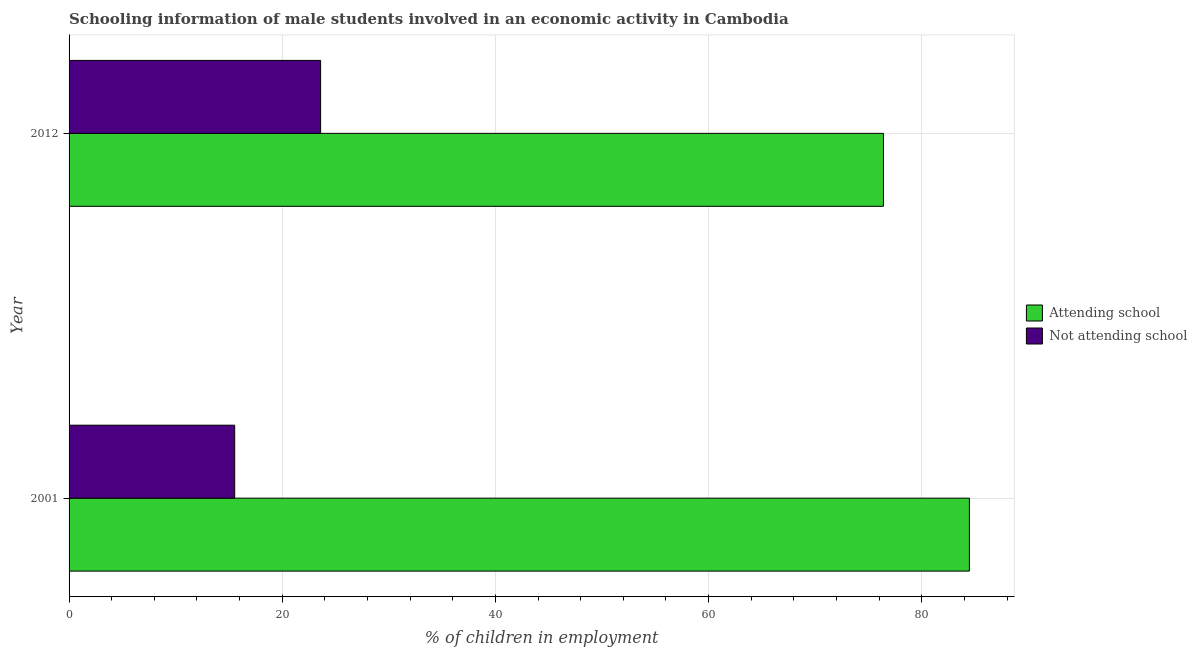How many groups of bars are there?
Provide a short and direct response. 2. Are the number of bars per tick equal to the number of legend labels?
Provide a short and direct response. Yes. Are the number of bars on each tick of the Y-axis equal?
Keep it short and to the point. Yes. What is the label of the 1st group of bars from the top?
Keep it short and to the point. 2012. What is the percentage of employed males who are attending school in 2001?
Make the answer very short. 84.46. Across all years, what is the maximum percentage of employed males who are not attending school?
Your response must be concise. 23.6. Across all years, what is the minimum percentage of employed males who are attending school?
Your answer should be very brief. 76.4. In which year was the percentage of employed males who are attending school maximum?
Ensure brevity in your answer.  2001. In which year was the percentage of employed males who are attending school minimum?
Provide a short and direct response. 2012. What is the total percentage of employed males who are attending school in the graph?
Make the answer very short. 160.86. What is the difference between the percentage of employed males who are not attending school in 2001 and that in 2012?
Ensure brevity in your answer.  -8.06. What is the difference between the percentage of employed males who are attending school in 2012 and the percentage of employed males who are not attending school in 2001?
Your answer should be very brief. 60.86. What is the average percentage of employed males who are not attending school per year?
Your answer should be very brief. 19.57. In the year 2001, what is the difference between the percentage of employed males who are not attending school and percentage of employed males who are attending school?
Provide a succinct answer. -68.93. In how many years, is the percentage of employed males who are attending school greater than 24 %?
Ensure brevity in your answer.  2. What is the ratio of the percentage of employed males who are not attending school in 2001 to that in 2012?
Keep it short and to the point. 0.66. Is the percentage of employed males who are attending school in 2001 less than that in 2012?
Make the answer very short. No. In how many years, is the percentage of employed males who are attending school greater than the average percentage of employed males who are attending school taken over all years?
Offer a terse response. 1. What does the 1st bar from the top in 2012 represents?
Offer a terse response. Not attending school. What does the 1st bar from the bottom in 2001 represents?
Make the answer very short. Attending school. What is the difference between two consecutive major ticks on the X-axis?
Make the answer very short. 20. Are the values on the major ticks of X-axis written in scientific E-notation?
Offer a terse response. No. Does the graph contain any zero values?
Offer a very short reply. No. How many legend labels are there?
Provide a short and direct response. 2. What is the title of the graph?
Your answer should be very brief. Schooling information of male students involved in an economic activity in Cambodia. Does "Primary school" appear as one of the legend labels in the graph?
Provide a short and direct response. No. What is the label or title of the X-axis?
Your answer should be very brief. % of children in employment. What is the % of children in employment in Attending school in 2001?
Ensure brevity in your answer.  84.46. What is the % of children in employment of Not attending school in 2001?
Keep it short and to the point. 15.54. What is the % of children in employment of Attending school in 2012?
Give a very brief answer. 76.4. What is the % of children in employment in Not attending school in 2012?
Provide a succinct answer. 23.6. Across all years, what is the maximum % of children in employment of Attending school?
Your answer should be very brief. 84.46. Across all years, what is the maximum % of children in employment in Not attending school?
Your answer should be very brief. 23.6. Across all years, what is the minimum % of children in employment of Attending school?
Offer a terse response. 76.4. Across all years, what is the minimum % of children in employment of Not attending school?
Provide a short and direct response. 15.54. What is the total % of children in employment of Attending school in the graph?
Offer a very short reply. 160.86. What is the total % of children in employment of Not attending school in the graph?
Keep it short and to the point. 39.14. What is the difference between the % of children in employment in Attending school in 2001 and that in 2012?
Your answer should be compact. 8.06. What is the difference between the % of children in employment in Not attending school in 2001 and that in 2012?
Your response must be concise. -8.06. What is the difference between the % of children in employment in Attending school in 2001 and the % of children in employment in Not attending school in 2012?
Offer a very short reply. 60.86. What is the average % of children in employment in Attending school per year?
Keep it short and to the point. 80.43. What is the average % of children in employment in Not attending school per year?
Ensure brevity in your answer.  19.57. In the year 2001, what is the difference between the % of children in employment of Attending school and % of children in employment of Not attending school?
Your answer should be compact. 68.93. In the year 2012, what is the difference between the % of children in employment in Attending school and % of children in employment in Not attending school?
Your response must be concise. 52.8. What is the ratio of the % of children in employment in Attending school in 2001 to that in 2012?
Make the answer very short. 1.11. What is the ratio of the % of children in employment in Not attending school in 2001 to that in 2012?
Ensure brevity in your answer.  0.66. What is the difference between the highest and the second highest % of children in employment in Attending school?
Provide a succinct answer. 8.06. What is the difference between the highest and the second highest % of children in employment of Not attending school?
Offer a terse response. 8.06. What is the difference between the highest and the lowest % of children in employment of Attending school?
Offer a terse response. 8.06. What is the difference between the highest and the lowest % of children in employment in Not attending school?
Keep it short and to the point. 8.06. 